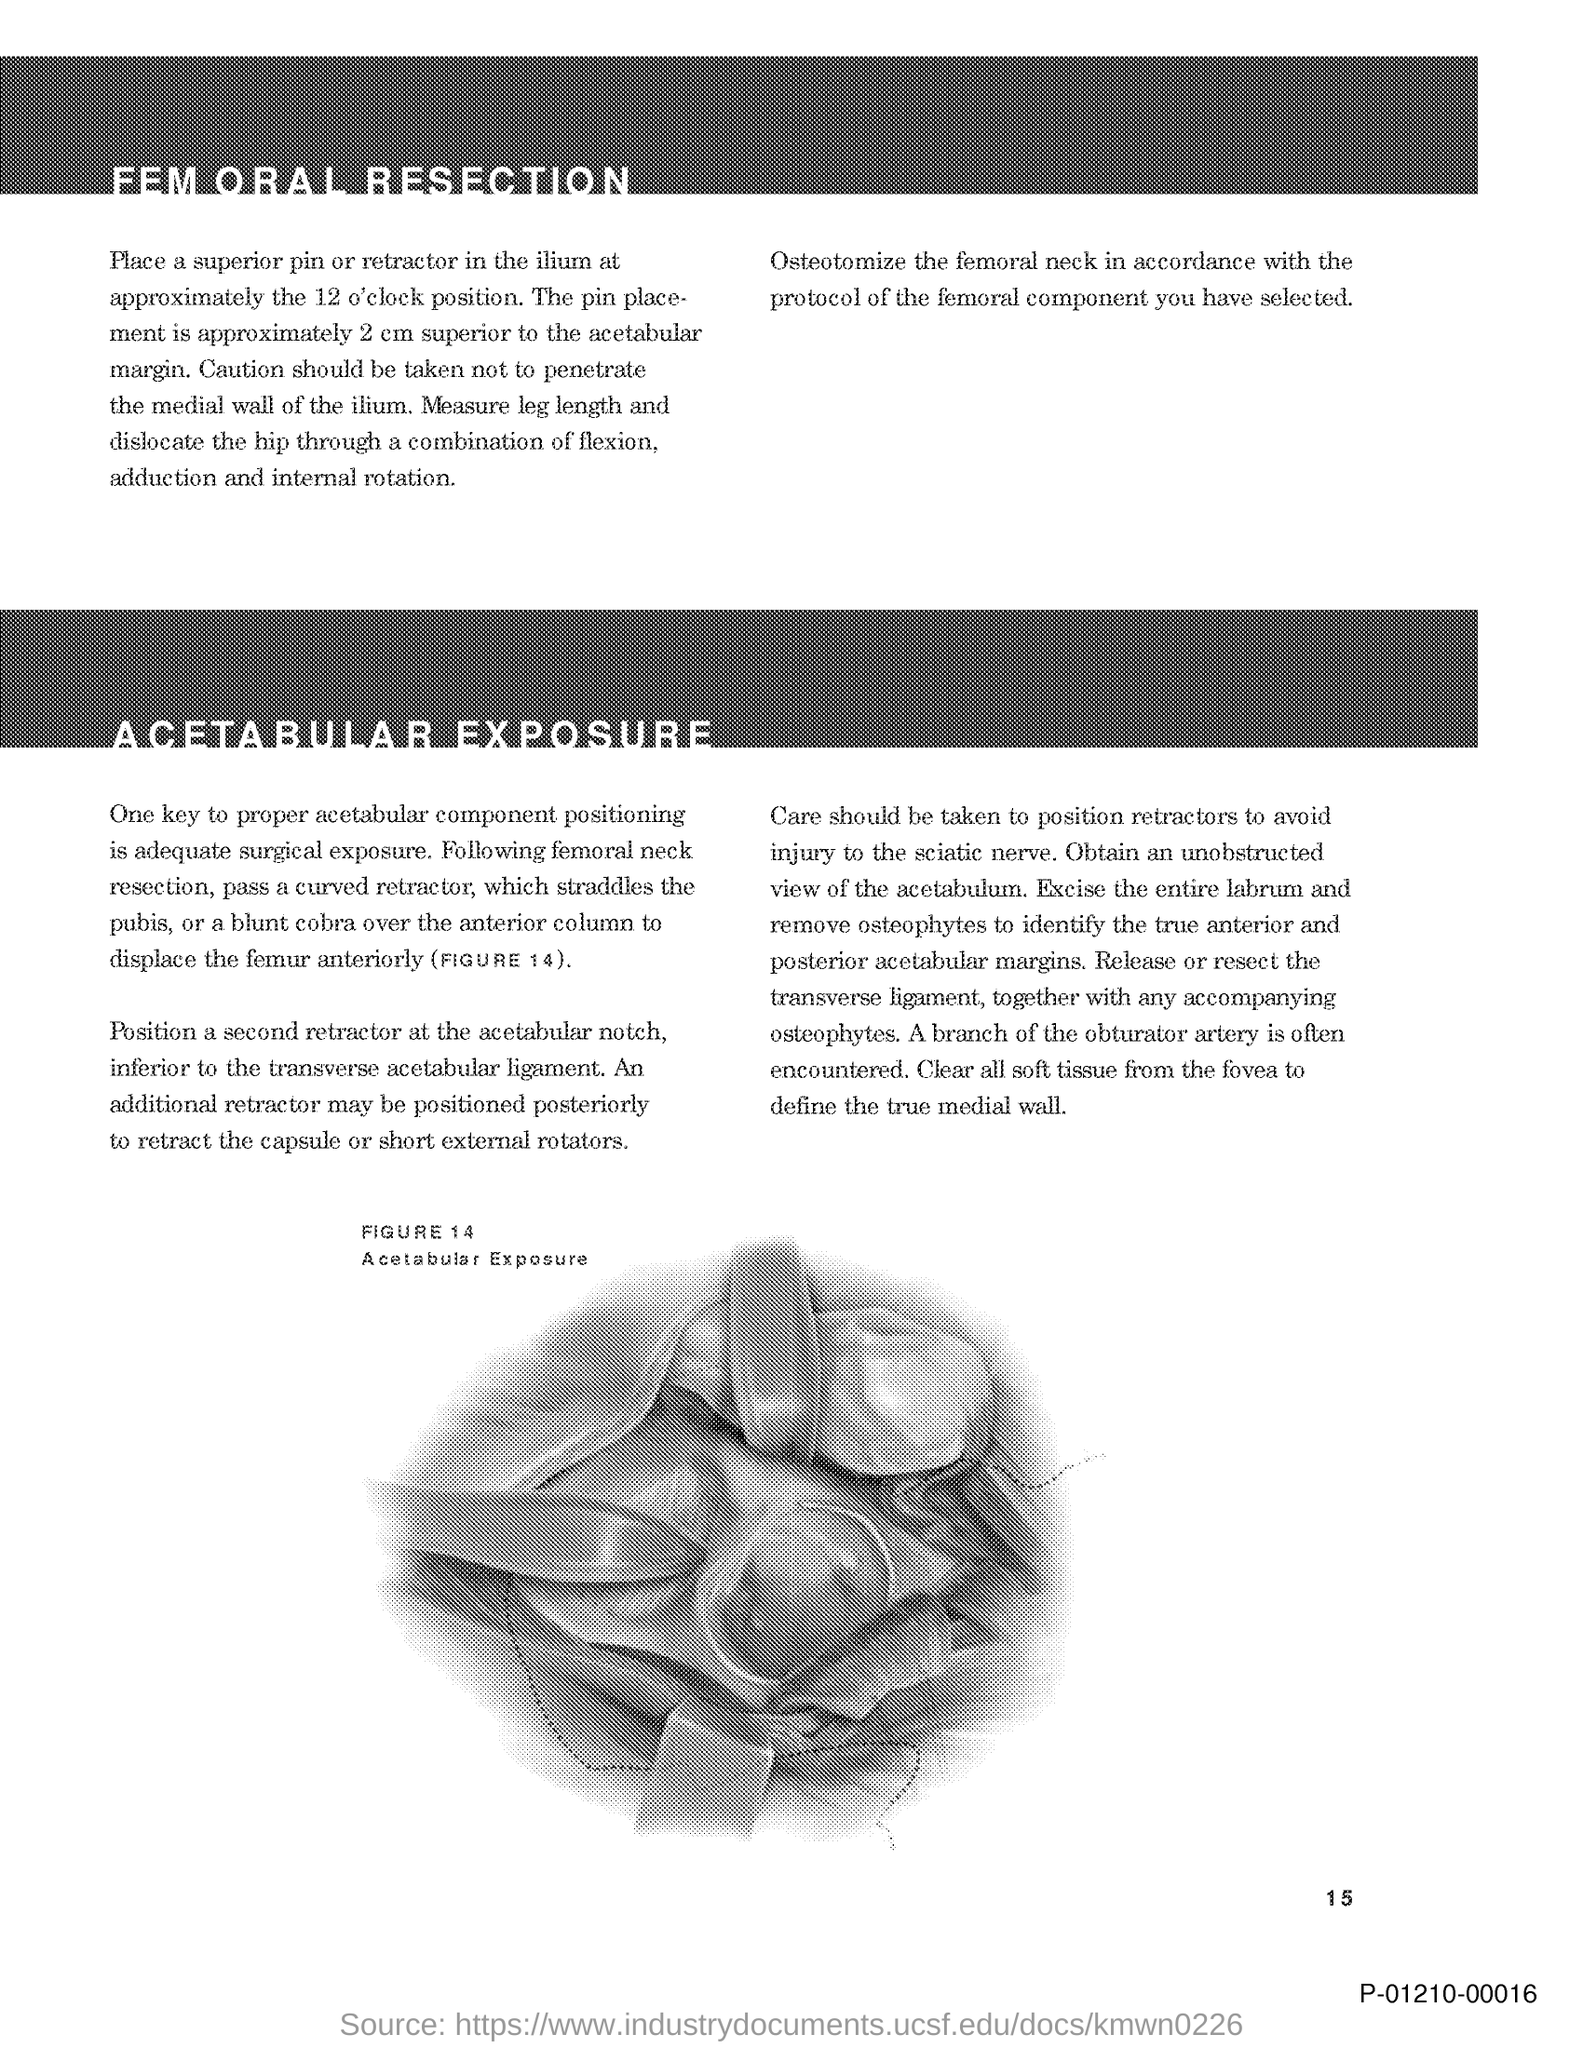Could you describe the significance of Figure 14 in this document? Figure 14 appears to illustrate an 'Acetabular Exposure', which is likely a visual aid to help understand the positioning of surgical instruments or anatomy during the hip surgery procedure described in the text. 